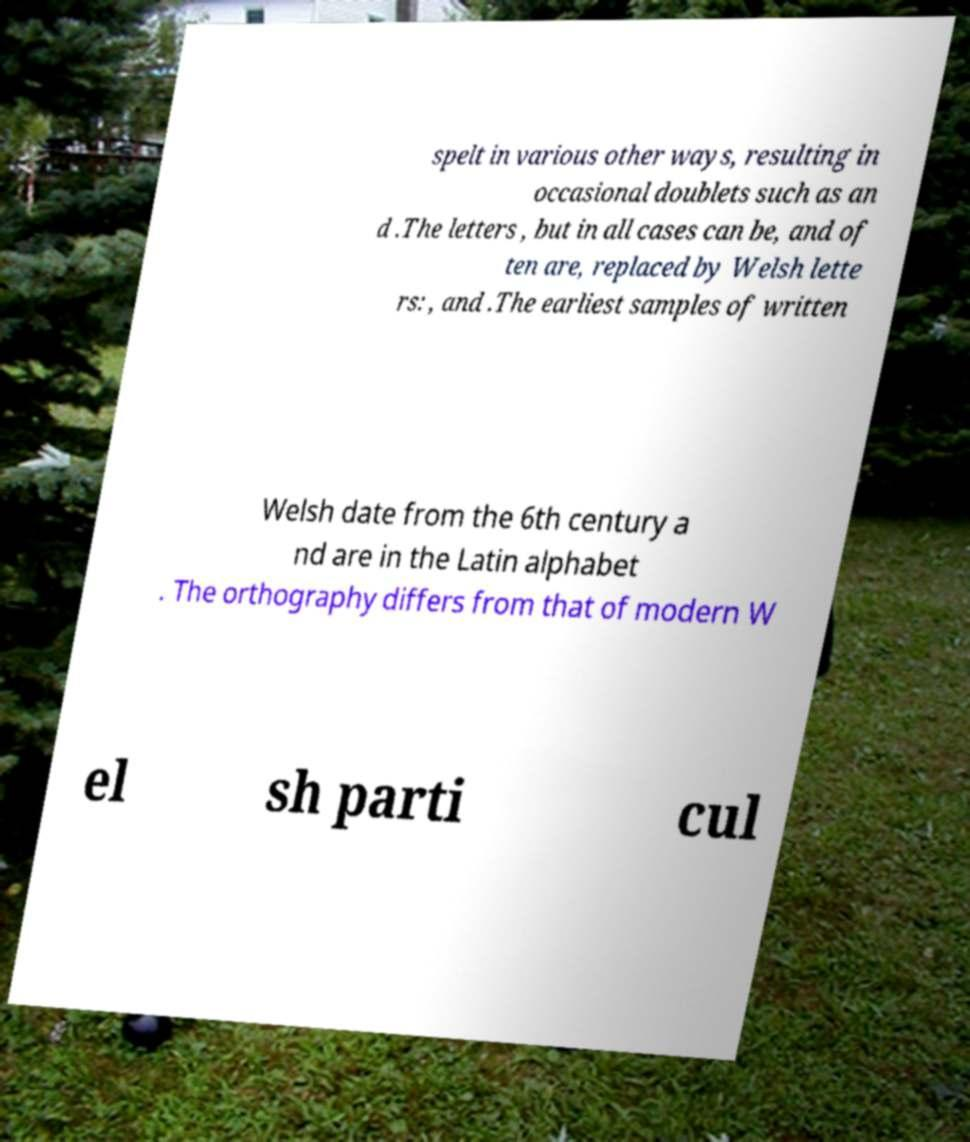Can you read and provide the text displayed in the image?This photo seems to have some interesting text. Can you extract and type it out for me? spelt in various other ways, resulting in occasional doublets such as an d .The letters , but in all cases can be, and of ten are, replaced by Welsh lette rs: , and .The earliest samples of written Welsh date from the 6th century a nd are in the Latin alphabet . The orthography differs from that of modern W el sh parti cul 